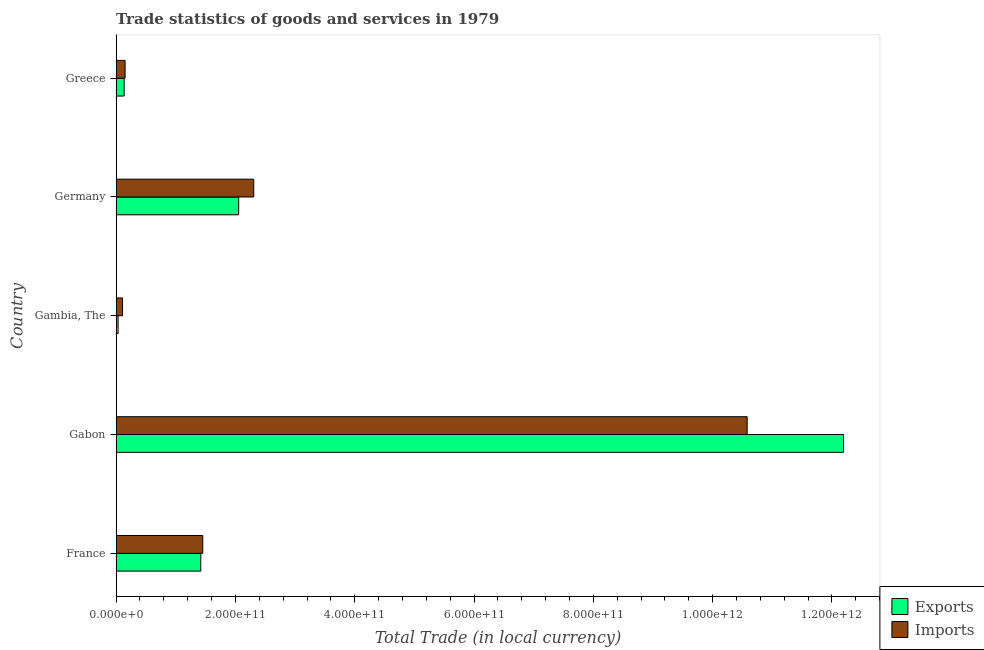How many different coloured bars are there?
Make the answer very short. 2. Are the number of bars on each tick of the Y-axis equal?
Your answer should be very brief. Yes. What is the label of the 4th group of bars from the top?
Your answer should be compact. Gabon. In how many cases, is the number of bars for a given country not equal to the number of legend labels?
Offer a very short reply. 0. What is the imports of goods and services in Germany?
Offer a terse response. 2.31e+11. Across all countries, what is the maximum export of goods and services?
Offer a terse response. 1.22e+12. Across all countries, what is the minimum imports of goods and services?
Provide a short and direct response. 1.07e+1. In which country was the export of goods and services maximum?
Offer a very short reply. Gabon. In which country was the imports of goods and services minimum?
Offer a terse response. Gambia, The. What is the total imports of goods and services in the graph?
Keep it short and to the point. 1.46e+12. What is the difference between the export of goods and services in France and that in Gambia, The?
Provide a short and direct response. 1.39e+11. What is the difference between the export of goods and services in Gambia, The and the imports of goods and services in France?
Your answer should be compact. -1.42e+11. What is the average export of goods and services per country?
Keep it short and to the point. 3.17e+11. What is the difference between the export of goods and services and imports of goods and services in Germany?
Make the answer very short. -2.52e+1. What is the ratio of the imports of goods and services in Gabon to that in Germany?
Provide a short and direct response. 4.58. What is the difference between the highest and the second highest imports of goods and services?
Ensure brevity in your answer.  8.27e+11. What is the difference between the highest and the lowest export of goods and services?
Your answer should be compact. 1.22e+12. In how many countries, is the export of goods and services greater than the average export of goods and services taken over all countries?
Make the answer very short. 1. Is the sum of the imports of goods and services in Gambia, The and Germany greater than the maximum export of goods and services across all countries?
Your answer should be very brief. No. What does the 1st bar from the top in Gambia, The represents?
Ensure brevity in your answer.  Imports. What does the 2nd bar from the bottom in Gambia, The represents?
Give a very brief answer. Imports. How many bars are there?
Give a very brief answer. 10. Are all the bars in the graph horizontal?
Offer a terse response. Yes. How many countries are there in the graph?
Make the answer very short. 5. What is the difference between two consecutive major ticks on the X-axis?
Keep it short and to the point. 2.00e+11. Are the values on the major ticks of X-axis written in scientific E-notation?
Ensure brevity in your answer.  Yes. Does the graph contain any zero values?
Your answer should be very brief. No. Does the graph contain grids?
Your response must be concise. No. Where does the legend appear in the graph?
Your answer should be compact. Bottom right. How are the legend labels stacked?
Offer a terse response. Vertical. What is the title of the graph?
Your answer should be compact. Trade statistics of goods and services in 1979. What is the label or title of the X-axis?
Provide a short and direct response. Total Trade (in local currency). What is the label or title of the Y-axis?
Provide a short and direct response. Country. What is the Total Trade (in local currency) in Exports in France?
Make the answer very short. 1.42e+11. What is the Total Trade (in local currency) in Imports in France?
Your answer should be very brief. 1.45e+11. What is the Total Trade (in local currency) in Exports in Gabon?
Ensure brevity in your answer.  1.22e+12. What is the Total Trade (in local currency) in Imports in Gabon?
Offer a very short reply. 1.06e+12. What is the Total Trade (in local currency) in Exports in Gambia, The?
Ensure brevity in your answer.  3.28e+09. What is the Total Trade (in local currency) in Imports in Gambia, The?
Make the answer very short. 1.07e+1. What is the Total Trade (in local currency) of Exports in Germany?
Provide a short and direct response. 2.05e+11. What is the Total Trade (in local currency) of Imports in Germany?
Make the answer very short. 2.31e+11. What is the Total Trade (in local currency) of Exports in Greece?
Provide a succinct answer. 1.34e+1. What is the Total Trade (in local currency) in Imports in Greece?
Keep it short and to the point. 1.51e+1. Across all countries, what is the maximum Total Trade (in local currency) in Exports?
Provide a succinct answer. 1.22e+12. Across all countries, what is the maximum Total Trade (in local currency) in Imports?
Your answer should be very brief. 1.06e+12. Across all countries, what is the minimum Total Trade (in local currency) of Exports?
Your response must be concise. 3.28e+09. Across all countries, what is the minimum Total Trade (in local currency) of Imports?
Ensure brevity in your answer.  1.07e+1. What is the total Total Trade (in local currency) in Exports in the graph?
Offer a very short reply. 1.58e+12. What is the total Total Trade (in local currency) of Imports in the graph?
Offer a terse response. 1.46e+12. What is the difference between the Total Trade (in local currency) of Exports in France and that in Gabon?
Offer a very short reply. -1.08e+12. What is the difference between the Total Trade (in local currency) in Imports in France and that in Gabon?
Offer a very short reply. -9.13e+11. What is the difference between the Total Trade (in local currency) in Exports in France and that in Gambia, The?
Your response must be concise. 1.39e+11. What is the difference between the Total Trade (in local currency) of Imports in France and that in Gambia, The?
Your response must be concise. 1.34e+11. What is the difference between the Total Trade (in local currency) in Exports in France and that in Germany?
Keep it short and to the point. -6.35e+1. What is the difference between the Total Trade (in local currency) in Imports in France and that in Germany?
Offer a very short reply. -8.54e+1. What is the difference between the Total Trade (in local currency) in Exports in France and that in Greece?
Provide a short and direct response. 1.28e+11. What is the difference between the Total Trade (in local currency) of Imports in France and that in Greece?
Provide a short and direct response. 1.30e+11. What is the difference between the Total Trade (in local currency) of Exports in Gabon and that in Gambia, The?
Ensure brevity in your answer.  1.22e+12. What is the difference between the Total Trade (in local currency) in Imports in Gabon and that in Gambia, The?
Your answer should be very brief. 1.05e+12. What is the difference between the Total Trade (in local currency) of Exports in Gabon and that in Germany?
Offer a very short reply. 1.01e+12. What is the difference between the Total Trade (in local currency) of Imports in Gabon and that in Germany?
Your answer should be very brief. 8.27e+11. What is the difference between the Total Trade (in local currency) of Exports in Gabon and that in Greece?
Offer a terse response. 1.21e+12. What is the difference between the Total Trade (in local currency) of Imports in Gabon and that in Greece?
Offer a terse response. 1.04e+12. What is the difference between the Total Trade (in local currency) of Exports in Gambia, The and that in Germany?
Your response must be concise. -2.02e+11. What is the difference between the Total Trade (in local currency) of Imports in Gambia, The and that in Germany?
Offer a very short reply. -2.20e+11. What is the difference between the Total Trade (in local currency) in Exports in Gambia, The and that in Greece?
Your answer should be very brief. -1.01e+1. What is the difference between the Total Trade (in local currency) of Imports in Gambia, The and that in Greece?
Your response must be concise. -4.32e+09. What is the difference between the Total Trade (in local currency) of Exports in Germany and that in Greece?
Provide a short and direct response. 1.92e+11. What is the difference between the Total Trade (in local currency) in Imports in Germany and that in Greece?
Keep it short and to the point. 2.16e+11. What is the difference between the Total Trade (in local currency) in Exports in France and the Total Trade (in local currency) in Imports in Gabon?
Make the answer very short. -9.16e+11. What is the difference between the Total Trade (in local currency) of Exports in France and the Total Trade (in local currency) of Imports in Gambia, The?
Your response must be concise. 1.31e+11. What is the difference between the Total Trade (in local currency) in Exports in France and the Total Trade (in local currency) in Imports in Germany?
Give a very brief answer. -8.88e+1. What is the difference between the Total Trade (in local currency) of Exports in France and the Total Trade (in local currency) of Imports in Greece?
Make the answer very short. 1.27e+11. What is the difference between the Total Trade (in local currency) in Exports in Gabon and the Total Trade (in local currency) in Imports in Gambia, The?
Make the answer very short. 1.21e+12. What is the difference between the Total Trade (in local currency) of Exports in Gabon and the Total Trade (in local currency) of Imports in Germany?
Provide a short and direct response. 9.89e+11. What is the difference between the Total Trade (in local currency) in Exports in Gabon and the Total Trade (in local currency) in Imports in Greece?
Offer a very short reply. 1.20e+12. What is the difference between the Total Trade (in local currency) in Exports in Gambia, The and the Total Trade (in local currency) in Imports in Germany?
Provide a short and direct response. -2.27e+11. What is the difference between the Total Trade (in local currency) in Exports in Gambia, The and the Total Trade (in local currency) in Imports in Greece?
Your answer should be compact. -1.18e+1. What is the difference between the Total Trade (in local currency) in Exports in Germany and the Total Trade (in local currency) in Imports in Greece?
Your answer should be compact. 1.90e+11. What is the average Total Trade (in local currency) in Exports per country?
Offer a terse response. 3.17e+11. What is the average Total Trade (in local currency) in Imports per country?
Offer a terse response. 2.92e+11. What is the difference between the Total Trade (in local currency) in Exports and Total Trade (in local currency) in Imports in France?
Keep it short and to the point. -3.35e+09. What is the difference between the Total Trade (in local currency) in Exports and Total Trade (in local currency) in Imports in Gabon?
Offer a very short reply. 1.62e+11. What is the difference between the Total Trade (in local currency) in Exports and Total Trade (in local currency) in Imports in Gambia, The?
Keep it short and to the point. -7.46e+09. What is the difference between the Total Trade (in local currency) of Exports and Total Trade (in local currency) of Imports in Germany?
Offer a terse response. -2.52e+1. What is the difference between the Total Trade (in local currency) in Exports and Total Trade (in local currency) in Imports in Greece?
Offer a very short reply. -1.64e+09. What is the ratio of the Total Trade (in local currency) in Exports in France to that in Gabon?
Give a very brief answer. 0.12. What is the ratio of the Total Trade (in local currency) of Imports in France to that in Gabon?
Provide a short and direct response. 0.14. What is the ratio of the Total Trade (in local currency) of Exports in France to that in Gambia, The?
Keep it short and to the point. 43.21. What is the ratio of the Total Trade (in local currency) of Imports in France to that in Gambia, The?
Keep it short and to the point. 13.52. What is the ratio of the Total Trade (in local currency) of Exports in France to that in Germany?
Provide a succinct answer. 0.69. What is the ratio of the Total Trade (in local currency) in Imports in France to that in Germany?
Offer a very short reply. 0.63. What is the ratio of the Total Trade (in local currency) of Exports in France to that in Greece?
Give a very brief answer. 10.57. What is the ratio of the Total Trade (in local currency) of Imports in France to that in Greece?
Offer a very short reply. 9.64. What is the ratio of the Total Trade (in local currency) in Exports in Gabon to that in Gambia, The?
Give a very brief answer. 371.31. What is the ratio of the Total Trade (in local currency) of Imports in Gabon to that in Gambia, The?
Keep it short and to the point. 98.44. What is the ratio of the Total Trade (in local currency) of Exports in Gabon to that in Germany?
Offer a terse response. 5.94. What is the ratio of the Total Trade (in local currency) in Imports in Gabon to that in Germany?
Give a very brief answer. 4.59. What is the ratio of the Total Trade (in local currency) of Exports in Gabon to that in Greece?
Provide a short and direct response. 90.84. What is the ratio of the Total Trade (in local currency) of Imports in Gabon to that in Greece?
Provide a succinct answer. 70.22. What is the ratio of the Total Trade (in local currency) of Exports in Gambia, The to that in Germany?
Make the answer very short. 0.02. What is the ratio of the Total Trade (in local currency) of Imports in Gambia, The to that in Germany?
Ensure brevity in your answer.  0.05. What is the ratio of the Total Trade (in local currency) of Exports in Gambia, The to that in Greece?
Offer a very short reply. 0.24. What is the ratio of the Total Trade (in local currency) of Imports in Gambia, The to that in Greece?
Provide a succinct answer. 0.71. What is the ratio of the Total Trade (in local currency) in Exports in Germany to that in Greece?
Offer a very short reply. 15.31. What is the ratio of the Total Trade (in local currency) of Imports in Germany to that in Greece?
Keep it short and to the point. 15.31. What is the difference between the highest and the second highest Total Trade (in local currency) of Exports?
Your answer should be compact. 1.01e+12. What is the difference between the highest and the second highest Total Trade (in local currency) in Imports?
Provide a short and direct response. 8.27e+11. What is the difference between the highest and the lowest Total Trade (in local currency) of Exports?
Offer a very short reply. 1.22e+12. What is the difference between the highest and the lowest Total Trade (in local currency) in Imports?
Your response must be concise. 1.05e+12. 